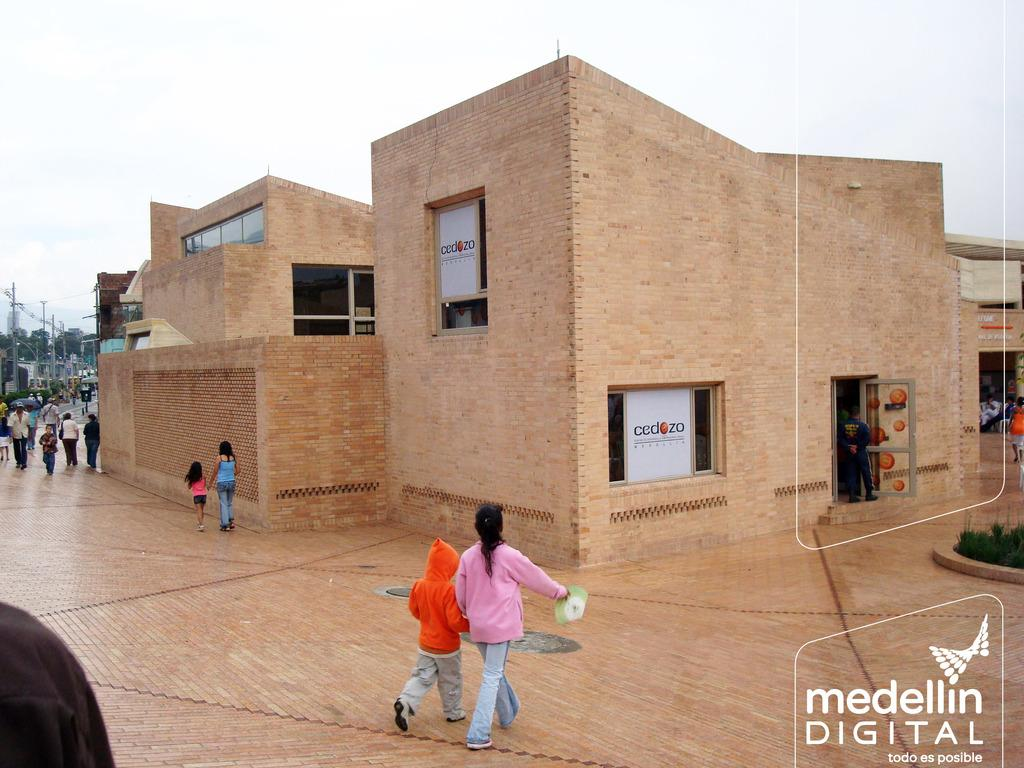What are the people in the image doing? The people in the image are walking. On what surface are the people walking? The people are walking on the floor. What can be seen in the background of the image? There is a building in the background of the image. What is on the left side of the image? There is a street on the left side of the image. What is visible above the street? The sky is visible above the street. Can you see a pencil being used by the people walking in the image? There is no pencil visible in the image, and it is not mentioned that the people are using any writing instruments. 